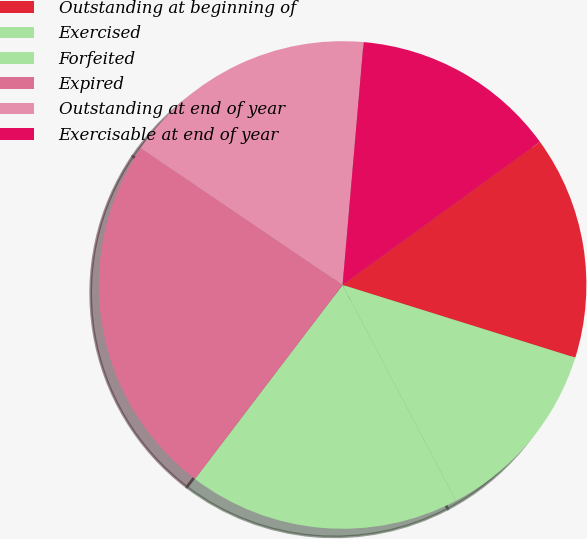<chart> <loc_0><loc_0><loc_500><loc_500><pie_chart><fcel>Outstanding at beginning of<fcel>Exercised<fcel>Forfeited<fcel>Expired<fcel>Outstanding at end of year<fcel>Exercisable at end of year<nl><fcel>14.81%<fcel>12.48%<fcel>18.05%<fcel>24.13%<fcel>16.89%<fcel>13.64%<nl></chart> 